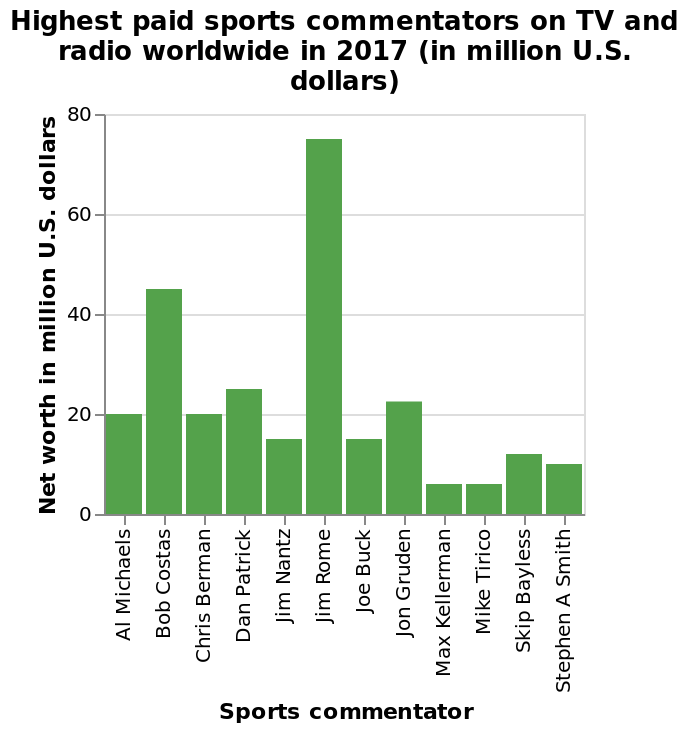<image>
What is the title of the bar plot? The title of the bar plot is "Highest paid sports commentators on TV and radio worldwide in 2017 (in million U.S. dollars)." 